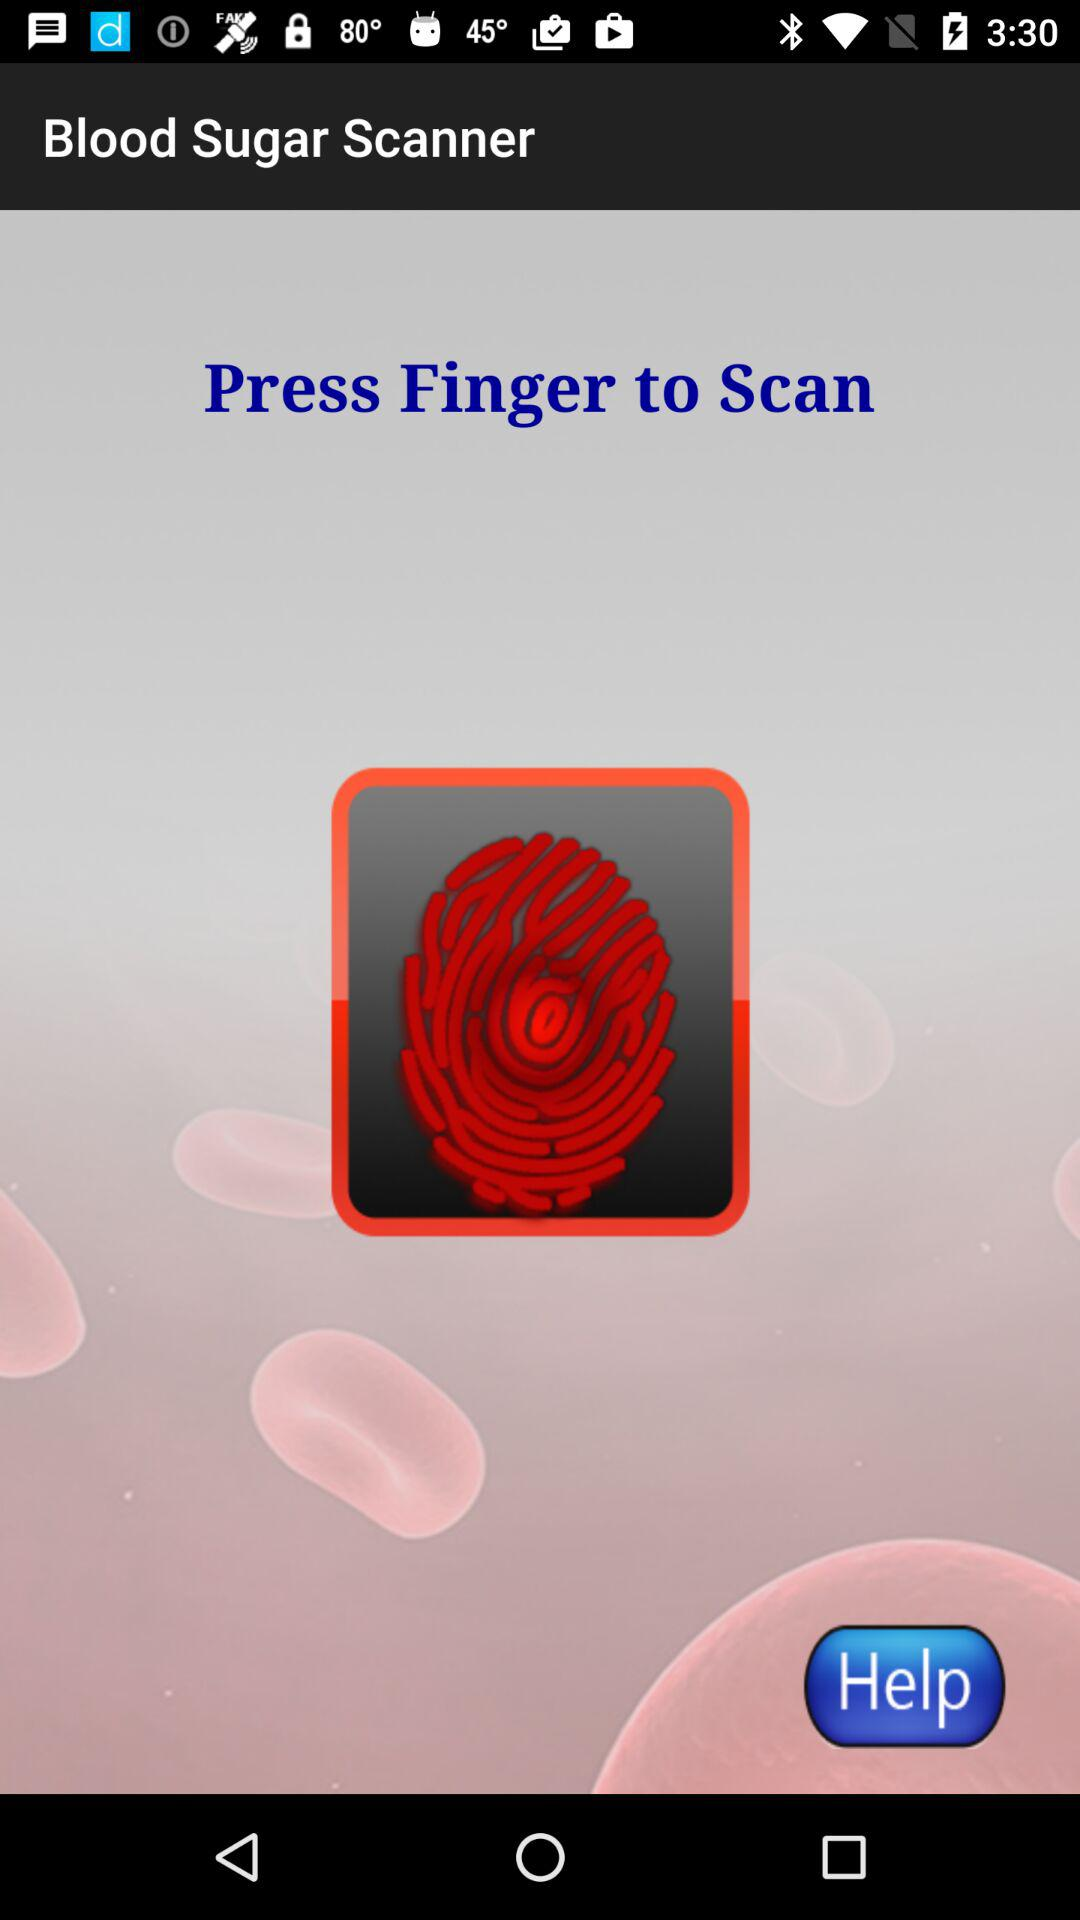What is the name of the application? The name of the application is "Blood Sugar Scanner". 